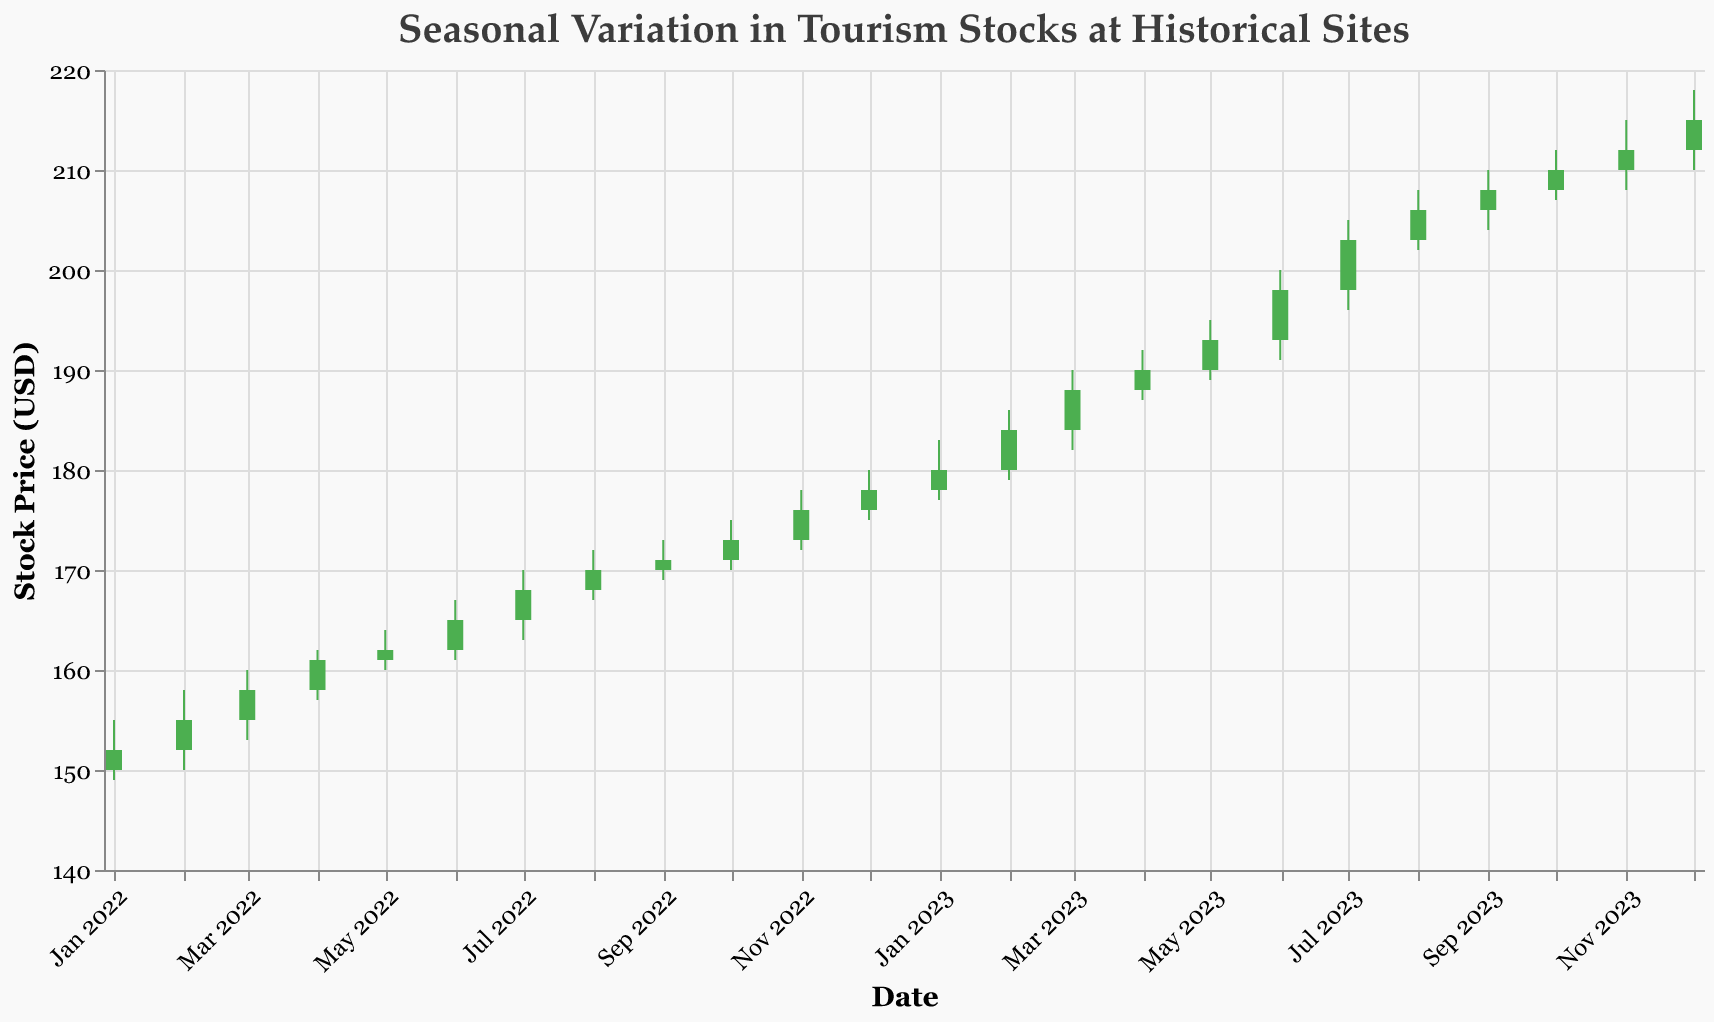What is the highest stock price in the plot? The highest stock price can be observed by looking for the highest point on the vertical axis (Y-axis) labeled as "Stock Price (USD)" across all data points. The highest value is $218.00 on December 2023.
Answer: $218.00 What is the trend in stock prices from January to December 2023? To determine the trend, observe the monthly closing prices from January to December 2023 in sequential order. Starting from January ($180.00) to December ($215.00), the prices exhibit an upward trend.
Answer: Upward trend Which month had the greatest increase in stock price within a single month? To find the month with the greatest increase, subtract the opening price from the closing price for each month and identify the largest difference. The largest increase is seen in July 2023 with a change of $5.00 ($203.00 - $198.00).
Answer: July 2023 In which month was the trading volume the highest? To identify the highest trading volume, look at the data for each month and find the maximum value in the "Volume" column. The highest trading volume is 34,000 units in October 2023.
Answer: October 2023 What is the average closing stock price for the year 2023? To calculate the average, sum the closing prices for each month in 2023 and divide by the number of months (12). Total closing prices sum up to 2,397 and dividing by 12 gives approximately $199.75.
Answer: Approximately $199.75 Which two consecutive months show the smallest change in closing price? Examine the closing prices of each month, calculate the absolute differences between consecutive months, and identify the smallest difference. The smallest change occurs between November ($212.00) and December ($215.00) with a difference of $3.00.
Answer: November and December 2023 What is the lowest stock price observed in the plot and which month does it occur? The lowest stock price can be found by looking at the lowest point on the vertical axis (Y-axis) for each month's "Low" value. The lowest price is $149.00 in January 2022.
Answer: $149.00 in January 2022 How much did the stock price change from the beginning to the end of 2022? Subtract the closing price at the end of December 2022 from the opening price at the beginning of January 2022. The change is $178.00 - $150.00 = $28.00.
Answer: $28.00 